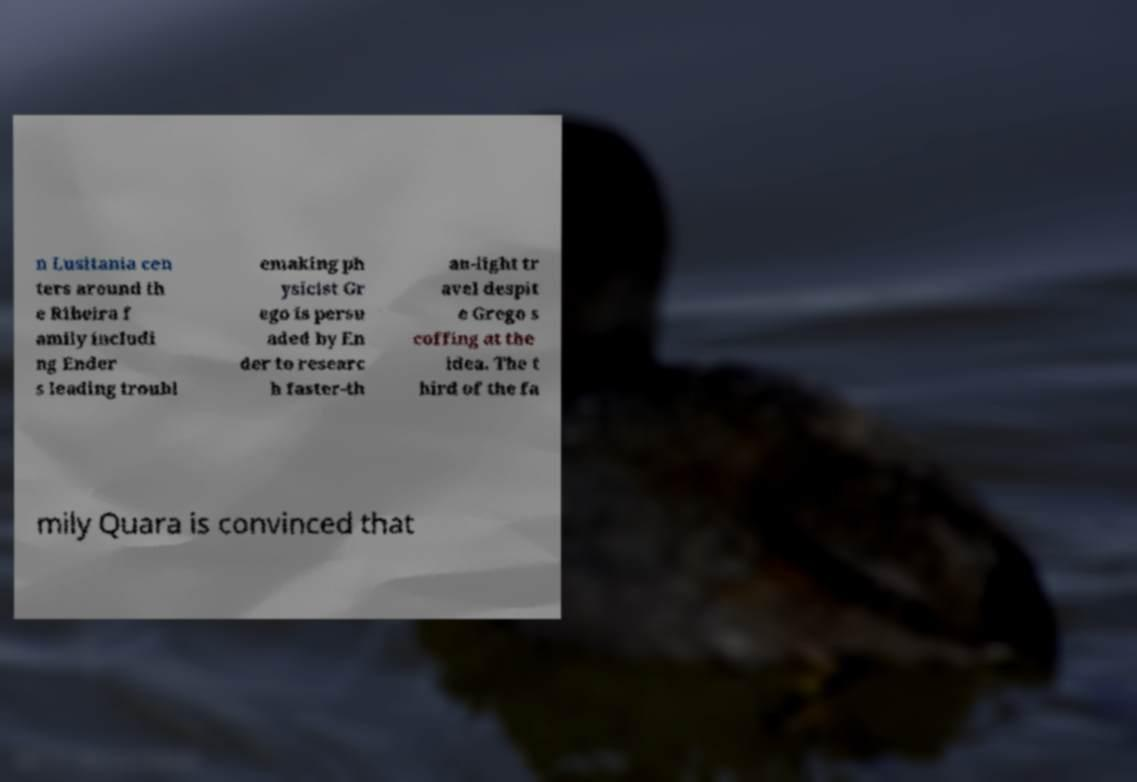There's text embedded in this image that I need extracted. Can you transcribe it verbatim? n Lusitania cen ters around th e Ribeira f amily includi ng Ender s leading troubl emaking ph ysicist Gr ego is persu aded by En der to researc h faster-th an-light tr avel despit e Grego s coffing at the idea. The t hird of the fa mily Quara is convinced that 